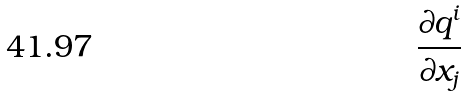<formula> <loc_0><loc_0><loc_500><loc_500>\frac { \partial q ^ { i } } { \partial x _ { j } }</formula> 